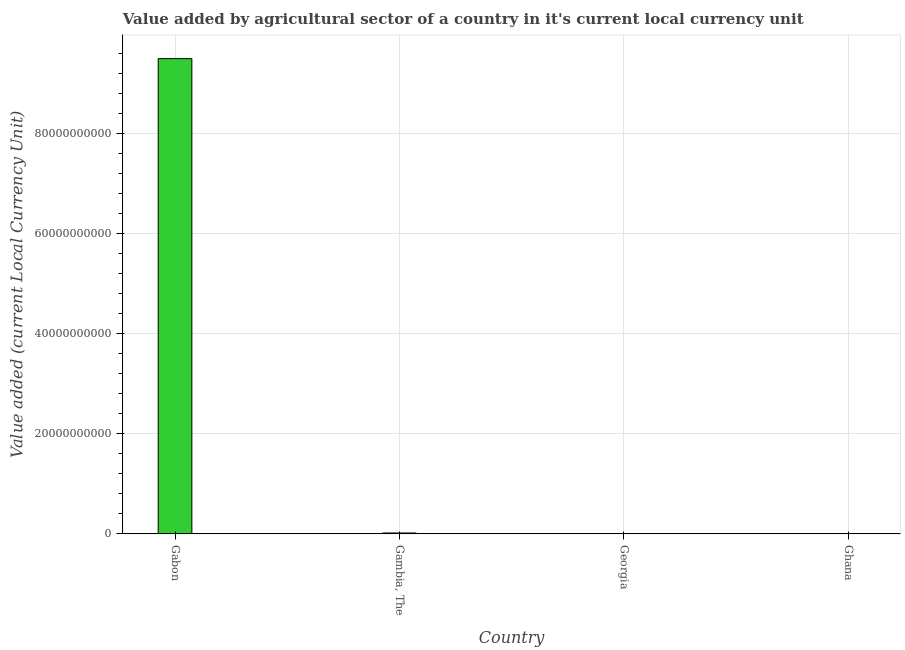Does the graph contain grids?
Provide a short and direct response. Yes. What is the title of the graph?
Offer a terse response. Value added by agricultural sector of a country in it's current local currency unit. What is the label or title of the Y-axis?
Offer a terse response. Value added (current Local Currency Unit). What is the value added by agriculture sector in Gabon?
Your answer should be compact. 9.50e+1. Across all countries, what is the maximum value added by agriculture sector?
Your answer should be compact. 9.50e+1. Across all countries, what is the minimum value added by agriculture sector?
Ensure brevity in your answer.  3400. In which country was the value added by agriculture sector maximum?
Make the answer very short. Gabon. In which country was the value added by agriculture sector minimum?
Provide a succinct answer. Georgia. What is the sum of the value added by agriculture sector?
Your answer should be very brief. 9.52e+1. What is the difference between the value added by agriculture sector in Gabon and Georgia?
Provide a short and direct response. 9.50e+1. What is the average value added by agriculture sector per country?
Your response must be concise. 2.38e+1. What is the median value added by agriculture sector?
Keep it short and to the point. 9.57e+07. In how many countries, is the value added by agriculture sector greater than 40000000000 LCU?
Provide a succinct answer. 1. What is the ratio of the value added by agriculture sector in Gabon to that in Georgia?
Make the answer very short. 2.79e+07. What is the difference between the highest and the second highest value added by agriculture sector?
Provide a short and direct response. 9.48e+1. What is the difference between the highest and the lowest value added by agriculture sector?
Give a very brief answer. 9.50e+1. How many bars are there?
Offer a very short reply. 4. Are all the bars in the graph horizontal?
Provide a short and direct response. No. What is the Value added (current Local Currency Unit) of Gabon?
Ensure brevity in your answer.  9.50e+1. What is the Value added (current Local Currency Unit) in Gambia, The?
Provide a succinct answer. 1.78e+08. What is the Value added (current Local Currency Unit) in Georgia?
Keep it short and to the point. 3400. What is the Value added (current Local Currency Unit) of Ghana?
Your response must be concise. 1.33e+07. What is the difference between the Value added (current Local Currency Unit) in Gabon and Gambia, The?
Give a very brief answer. 9.48e+1. What is the difference between the Value added (current Local Currency Unit) in Gabon and Georgia?
Give a very brief answer. 9.50e+1. What is the difference between the Value added (current Local Currency Unit) in Gabon and Ghana?
Your response must be concise. 9.50e+1. What is the difference between the Value added (current Local Currency Unit) in Gambia, The and Georgia?
Your answer should be compact. 1.78e+08. What is the difference between the Value added (current Local Currency Unit) in Gambia, The and Ghana?
Offer a very short reply. 1.65e+08. What is the difference between the Value added (current Local Currency Unit) in Georgia and Ghana?
Make the answer very short. -1.33e+07. What is the ratio of the Value added (current Local Currency Unit) in Gabon to that in Gambia, The?
Your answer should be very brief. 533.71. What is the ratio of the Value added (current Local Currency Unit) in Gabon to that in Georgia?
Your answer should be very brief. 2.79e+07. What is the ratio of the Value added (current Local Currency Unit) in Gabon to that in Ghana?
Provide a succinct answer. 7130.42. What is the ratio of the Value added (current Local Currency Unit) in Gambia, The to that in Georgia?
Keep it short and to the point. 5.24e+04. What is the ratio of the Value added (current Local Currency Unit) in Gambia, The to that in Ghana?
Keep it short and to the point. 13.36. What is the ratio of the Value added (current Local Currency Unit) in Georgia to that in Ghana?
Offer a terse response. 0. 